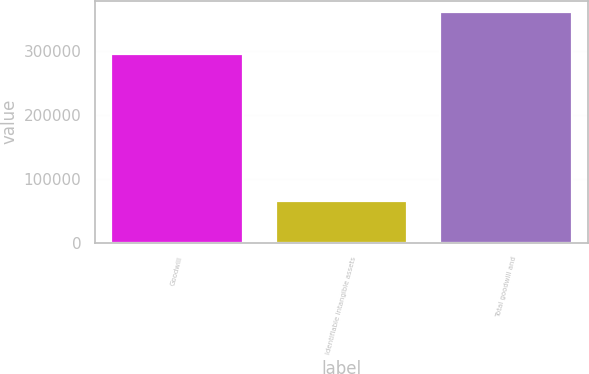<chart> <loc_0><loc_0><loc_500><loc_500><bar_chart><fcel>Goodwill<fcel>Identifiable intangible assets<fcel>Total goodwill and<nl><fcel>295486<fcel>65978<fcel>361464<nl></chart> 